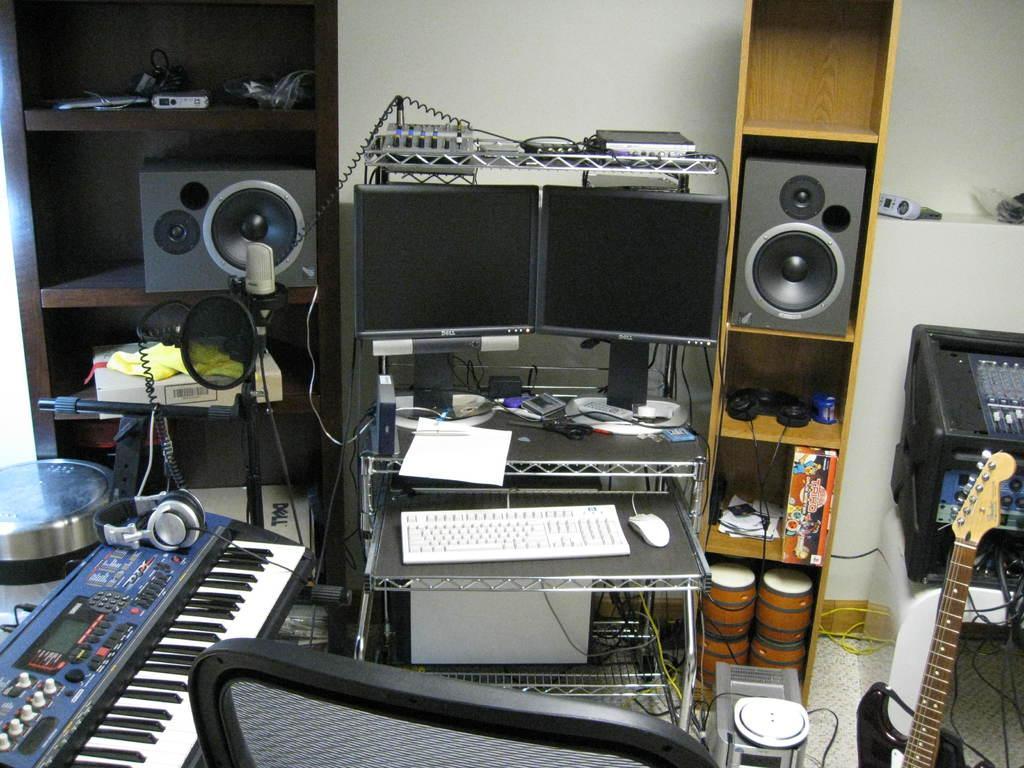Can you describe this image briefly? In this picture there is a inside view of the room. In the front there are two computer screens on the table with white keyboard and mouse. Behind there is a wooden box with black speakers. On the left side there is a piano and headphone and in the front bottom side there is a black chair. 